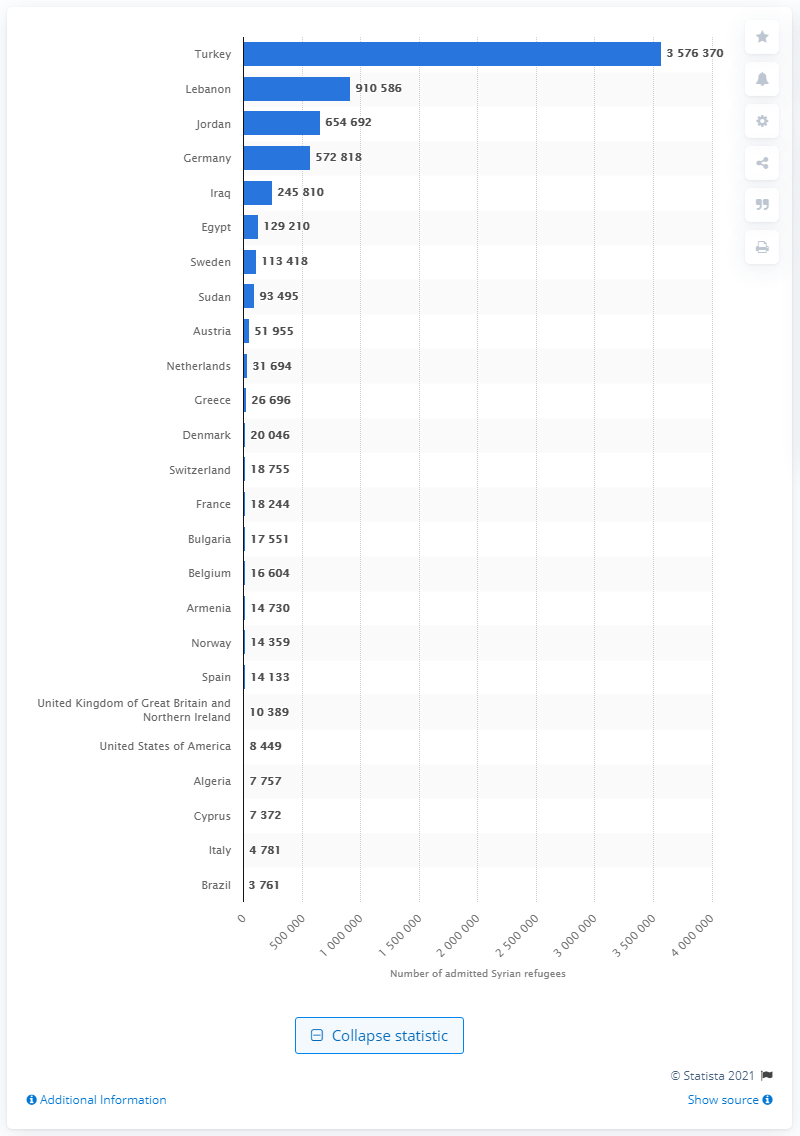Mention a couple of crucial points in this snapshot. At the end of 2019, there were approximately 3,576,370 Syrian refugees living in Turkey. 